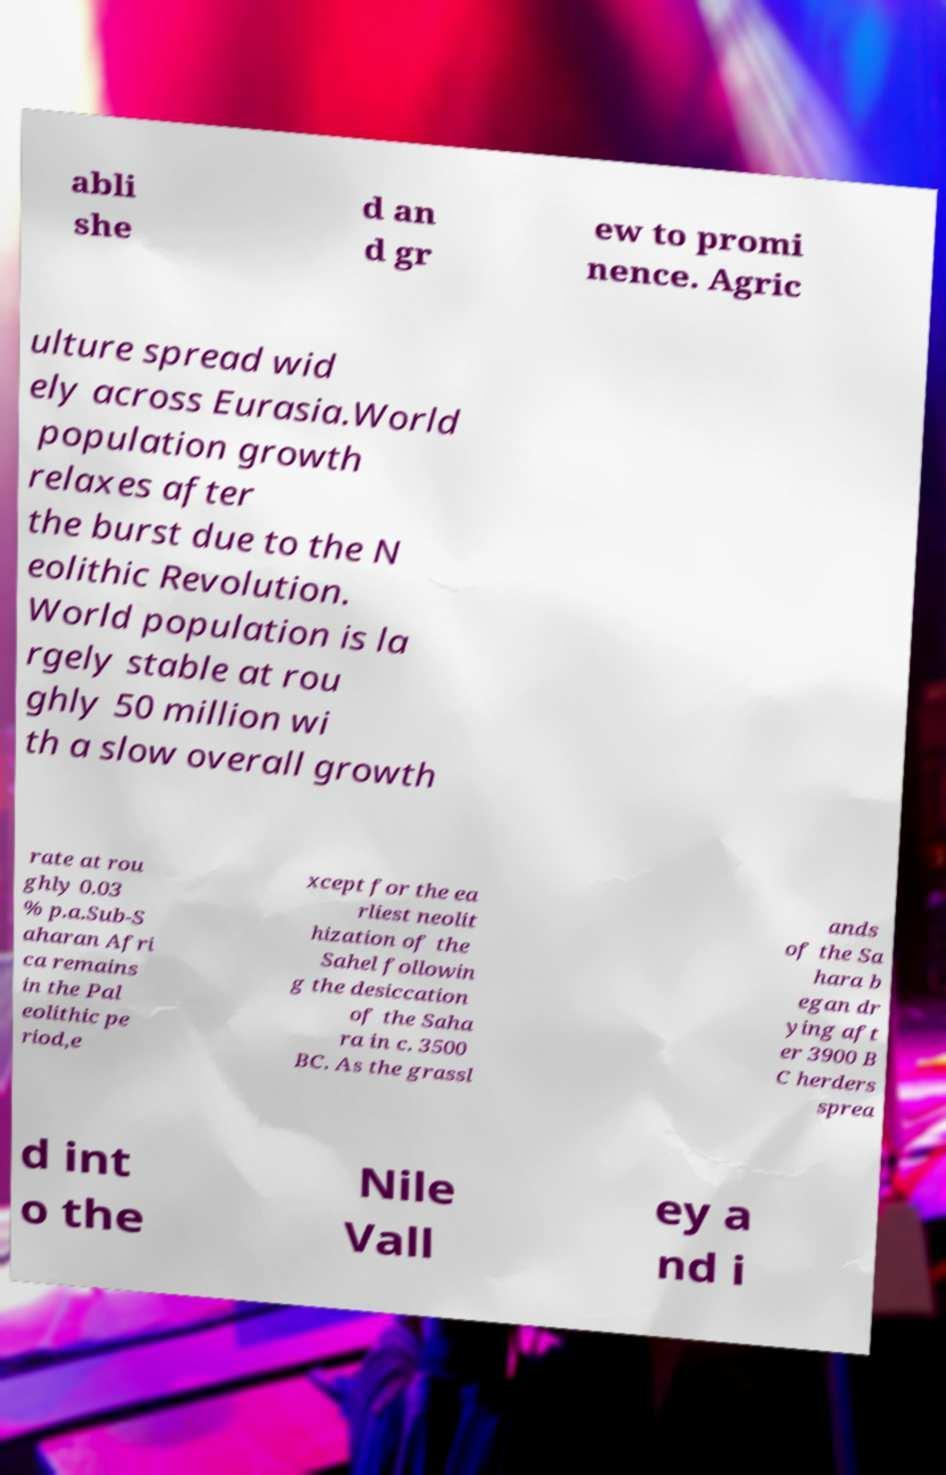Please read and relay the text visible in this image. What does it say? abli she d an d gr ew to promi nence. Agric ulture spread wid ely across Eurasia.World population growth relaxes after the burst due to the N eolithic Revolution. World population is la rgely stable at rou ghly 50 million wi th a slow overall growth rate at rou ghly 0.03 % p.a.Sub-S aharan Afri ca remains in the Pal eolithic pe riod,e xcept for the ea rliest neolit hization of the Sahel followin g the desiccation of the Saha ra in c. 3500 BC. As the grassl ands of the Sa hara b egan dr ying aft er 3900 B C herders sprea d int o the Nile Vall ey a nd i 